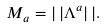<formula> <loc_0><loc_0><loc_500><loc_500>M _ { a } = | \, | \Lambda ^ { a } | \, | .</formula> 